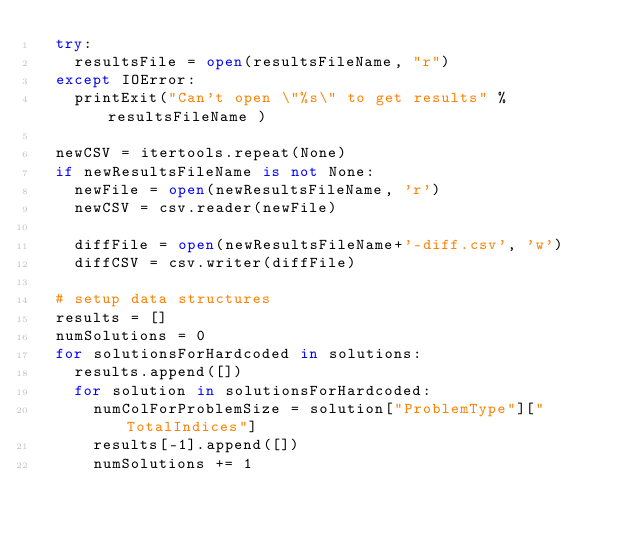Convert code to text. <code><loc_0><loc_0><loc_500><loc_500><_Python_>  try:
    resultsFile = open(resultsFileName, "r")
  except IOError:
    printExit("Can't open \"%s\" to get results" % resultsFileName )

  newCSV = itertools.repeat(None)
  if newResultsFileName is not None:
    newFile = open(newResultsFileName, 'r')
    newCSV = csv.reader(newFile)

    diffFile = open(newResultsFileName+'-diff.csv', 'w')
    diffCSV = csv.writer(diffFile)

  # setup data structures
  results = []
  numSolutions = 0
  for solutionsForHardcoded in solutions:
    results.append([])
    for solution in solutionsForHardcoded:
      numColForProblemSize = solution["ProblemType"]["TotalIndices"]
      results[-1].append([])
      numSolutions += 1
</code> 